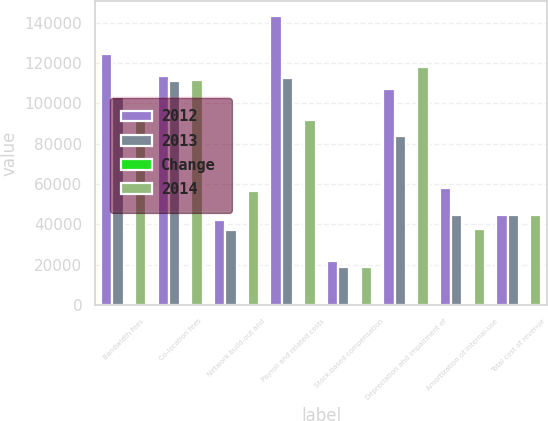Convert chart. <chart><loc_0><loc_0><loc_500><loc_500><stacked_bar_chart><ecel><fcel>Bandwidth fees<fcel>Co-location fees<fcel>Network build-out and<fcel>Payroll and related costs<fcel>Stock-based compensation<fcel>Depreciation and impairment of<fcel>Amortization of internal-use<fcel>Total cost of revenue<nl><fcel>2012<fcel>124470<fcel>113661<fcel>42114<fcel>143468<fcel>21866<fcel>107250<fcel>58114<fcel>44383<nl><fcel>2013<fcel>103344<fcel>111052<fcel>37123<fcel>112806<fcel>18568<fcel>83811<fcel>44383<fcel>44383<nl><fcel>Change<fcel>20.4<fcel>2.3<fcel>13.4<fcel>27.2<fcel>17.8<fcel>28<fcel>30.9<fcel>19.5<nl><fcel>2014<fcel>95185<fcel>111673<fcel>56598<fcel>91954<fcel>18731<fcel>117997<fcel>37762<fcel>44383<nl></chart> 